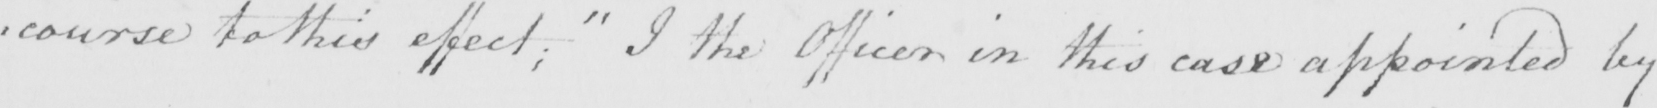What is written in this line of handwriting? : course to this effect ;  " I the Officer in this case appointed by 